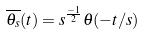<formula> <loc_0><loc_0><loc_500><loc_500>\overline { \theta _ { s } } ( t ) = s ^ { \frac { - 1 } { 2 } } \theta ( - t / s )</formula> 